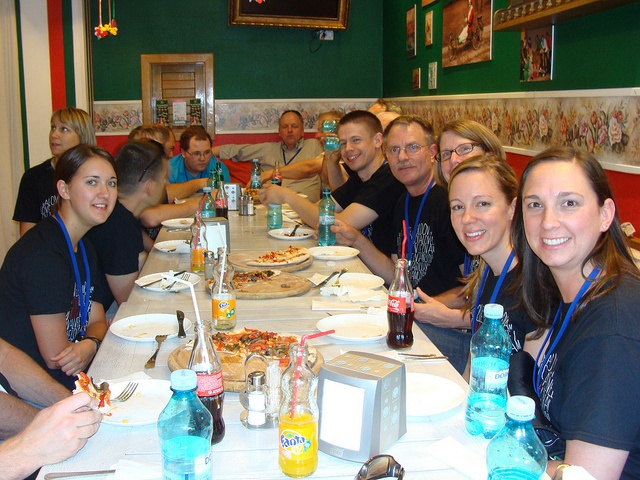Describe the objects in this image and their specific colors. I can see dining table in gray, white, tan, lightblue, and darkgray tones, people in gray, navy, black, lightpink, and darkblue tones, people in gray, black, and tan tones, dining table in gray, ivory, tan, and darkgray tones, and people in gray, black, tan, and navy tones in this image. 